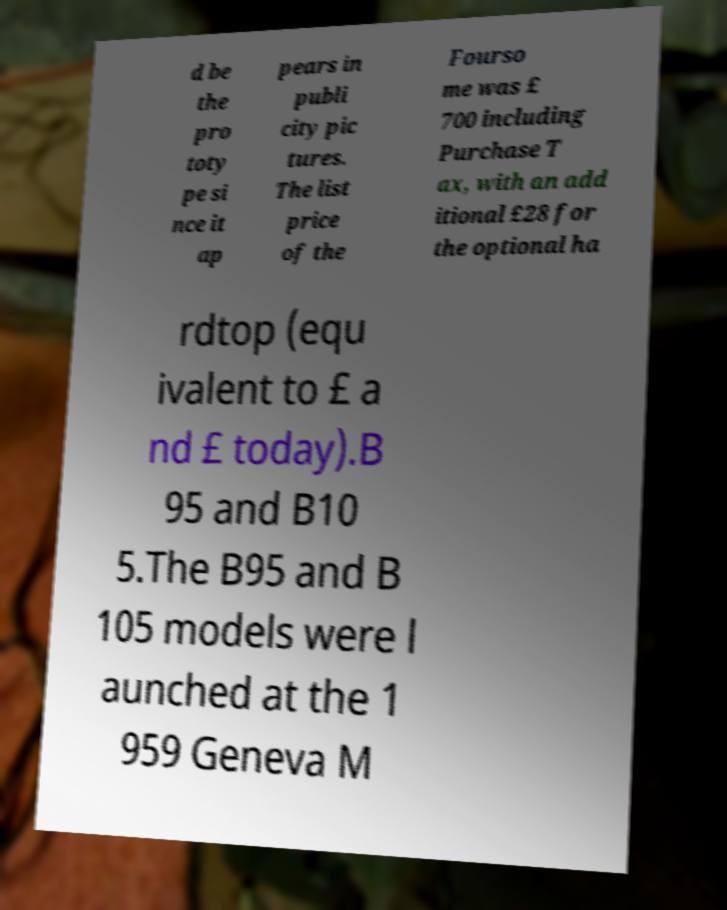There's text embedded in this image that I need extracted. Can you transcribe it verbatim? d be the pro toty pe si nce it ap pears in publi city pic tures. The list price of the Fourso me was £ 700 including Purchase T ax, with an add itional £28 for the optional ha rdtop (equ ivalent to £ a nd £ today).B 95 and B10 5.The B95 and B 105 models were l aunched at the 1 959 Geneva M 